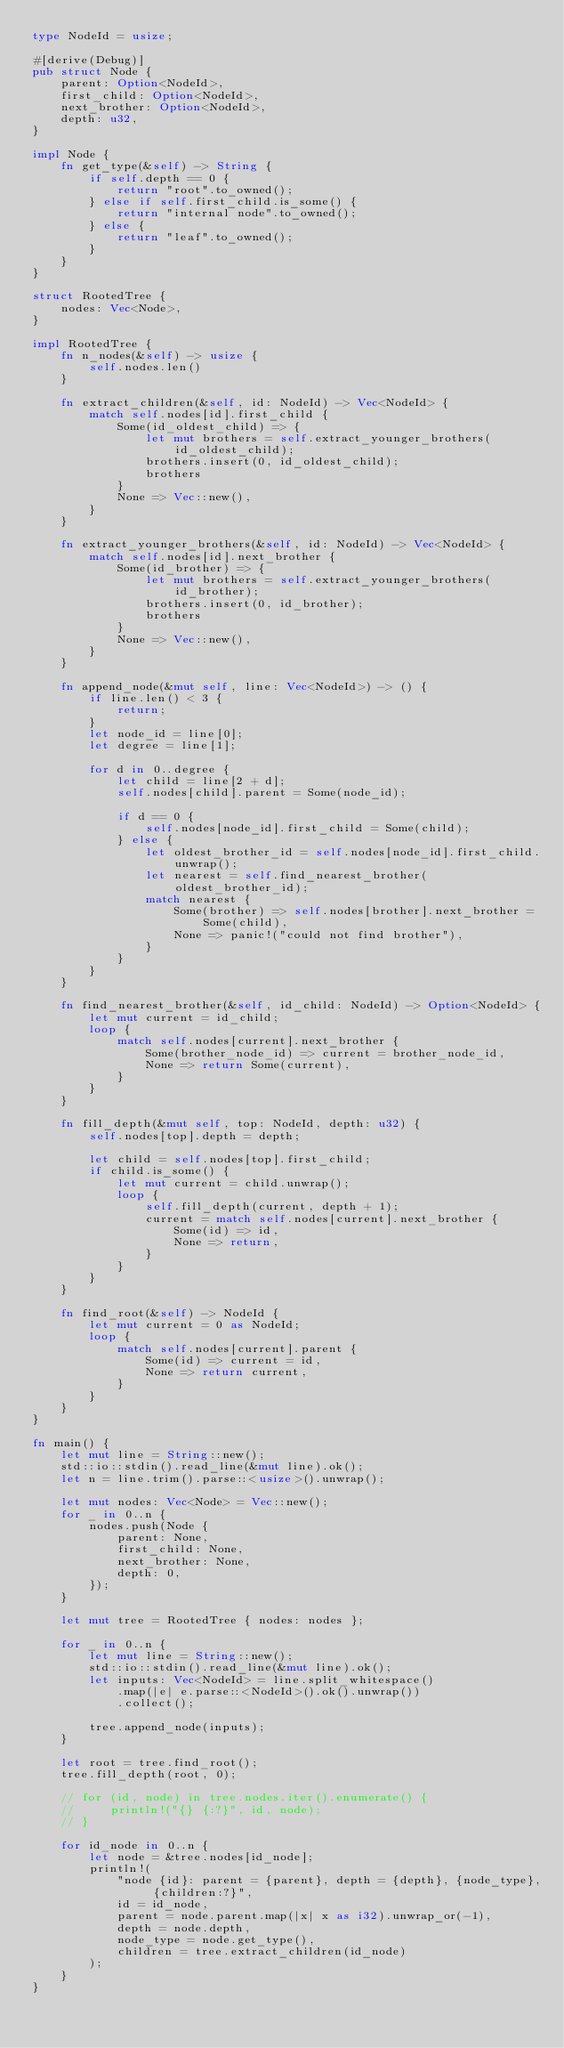<code> <loc_0><loc_0><loc_500><loc_500><_Rust_>type NodeId = usize;

#[derive(Debug)]
pub struct Node {
    parent: Option<NodeId>,
    first_child: Option<NodeId>,
    next_brother: Option<NodeId>,
    depth: u32,
}

impl Node {
    fn get_type(&self) -> String {
        if self.depth == 0 {
            return "root".to_owned();
        } else if self.first_child.is_some() {
            return "internal node".to_owned();
        } else {
            return "leaf".to_owned();
        }
    }
}

struct RootedTree {
    nodes: Vec<Node>,
}

impl RootedTree {
    fn n_nodes(&self) -> usize {
        self.nodes.len()
    }

    fn extract_children(&self, id: NodeId) -> Vec<NodeId> {
        match self.nodes[id].first_child {
            Some(id_oldest_child) => {
                let mut brothers = self.extract_younger_brothers(id_oldest_child);
                brothers.insert(0, id_oldest_child);
                brothers
            }
            None => Vec::new(),
        }
    }

    fn extract_younger_brothers(&self, id: NodeId) -> Vec<NodeId> {
        match self.nodes[id].next_brother {
            Some(id_brother) => {
                let mut brothers = self.extract_younger_brothers(id_brother);
                brothers.insert(0, id_brother);
                brothers
            }
            None => Vec::new(),
        }
    }

    fn append_node(&mut self, line: Vec<NodeId>) -> () {
        if line.len() < 3 {
            return;
        }
        let node_id = line[0];
        let degree = line[1];

        for d in 0..degree {
            let child = line[2 + d];
            self.nodes[child].parent = Some(node_id);

            if d == 0 {
                self.nodes[node_id].first_child = Some(child);
            } else {
                let oldest_brother_id = self.nodes[node_id].first_child.unwrap();
                let nearest = self.find_nearest_brother(oldest_brother_id);
                match nearest {
                    Some(brother) => self.nodes[brother].next_brother = Some(child),
                    None => panic!("could not find brother"),
                }
            }
        }
    }

    fn find_nearest_brother(&self, id_child: NodeId) -> Option<NodeId> {
        let mut current = id_child;
        loop {
            match self.nodes[current].next_brother {
                Some(brother_node_id) => current = brother_node_id,
                None => return Some(current),
            }
        }
    }

    fn fill_depth(&mut self, top: NodeId, depth: u32) {
        self.nodes[top].depth = depth;

        let child = self.nodes[top].first_child;
        if child.is_some() {
            let mut current = child.unwrap();
            loop {
                self.fill_depth(current, depth + 1);
                current = match self.nodes[current].next_brother {
                    Some(id) => id,
                    None => return,
                }
            }
        }
    }

    fn find_root(&self) -> NodeId {
        let mut current = 0 as NodeId;
        loop {
            match self.nodes[current].parent {
                Some(id) => current = id,
                None => return current,
            }
        }
    }
}

fn main() {
    let mut line = String::new();
    std::io::stdin().read_line(&mut line).ok();
    let n = line.trim().parse::<usize>().unwrap();

    let mut nodes: Vec<Node> = Vec::new();
    for _ in 0..n {
        nodes.push(Node {
            parent: None,
            first_child: None,
            next_brother: None,
            depth: 0,
        });
    }

    let mut tree = RootedTree { nodes: nodes };

    for _ in 0..n {
        let mut line = String::new();
        std::io::stdin().read_line(&mut line).ok();
        let inputs: Vec<NodeId> = line.split_whitespace()
            .map(|e| e.parse::<NodeId>().ok().unwrap())
            .collect();

        tree.append_node(inputs);
    }

    let root = tree.find_root();
    tree.fill_depth(root, 0);

    // for (id, node) in tree.nodes.iter().enumerate() {
    //     println!("{} {:?}", id, node);
    // }

    for id_node in 0..n {
        let node = &tree.nodes[id_node];
        println!(
            "node {id}: parent = {parent}, depth = {depth}, {node_type}, {children:?}",
            id = id_node,
            parent = node.parent.map(|x| x as i32).unwrap_or(-1),
            depth = node.depth,
            node_type = node.get_type(),
            children = tree.extract_children(id_node)
        );
    }
}

</code> 